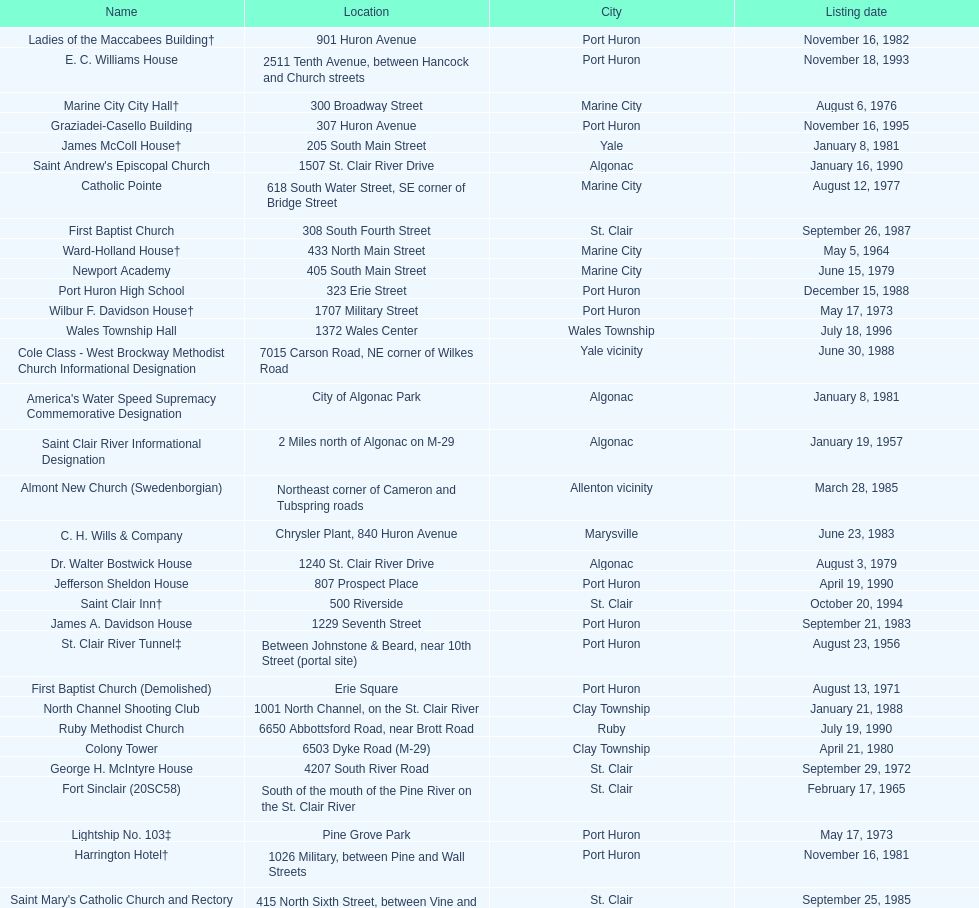What is the number of properties on the list that have been demolished? 2. 